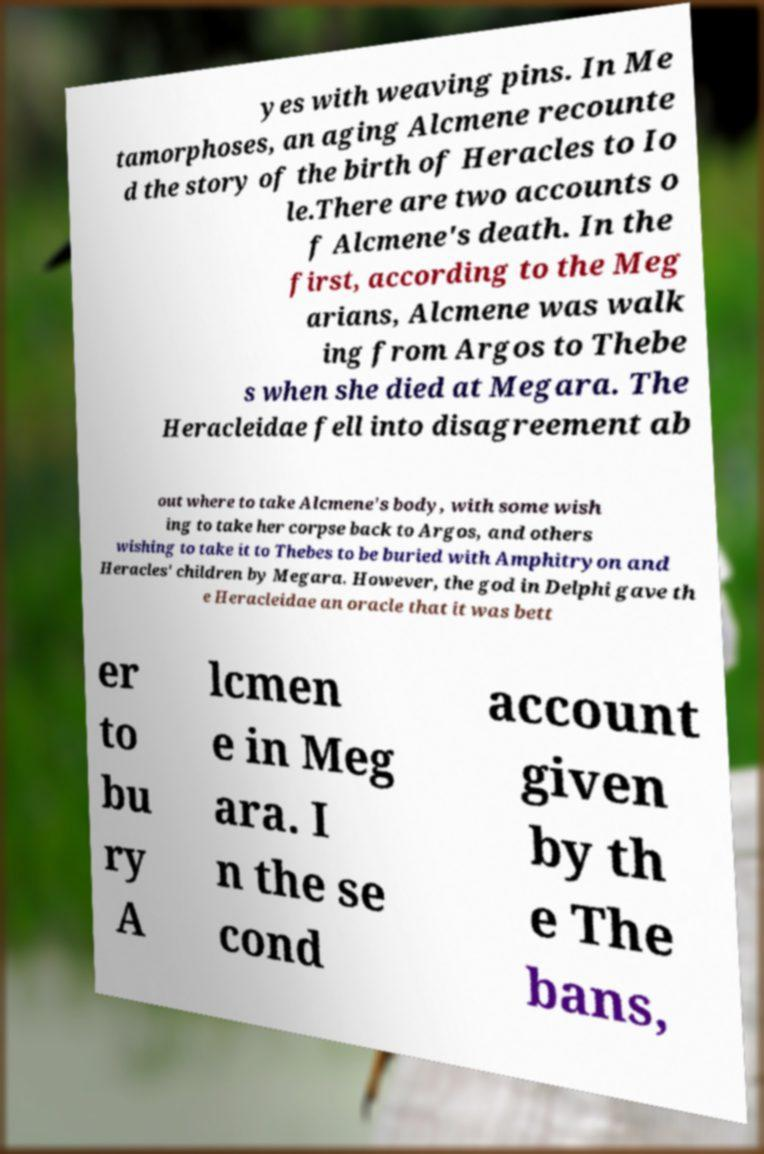I need the written content from this picture converted into text. Can you do that? yes with weaving pins. In Me tamorphoses, an aging Alcmene recounte d the story of the birth of Heracles to Io le.There are two accounts o f Alcmene's death. In the first, according to the Meg arians, Alcmene was walk ing from Argos to Thebe s when she died at Megara. The Heracleidae fell into disagreement ab out where to take Alcmene's body, with some wish ing to take her corpse back to Argos, and others wishing to take it to Thebes to be buried with Amphitryon and Heracles' children by Megara. However, the god in Delphi gave th e Heracleidae an oracle that it was bett er to bu ry A lcmen e in Meg ara. I n the se cond account given by th e The bans, 